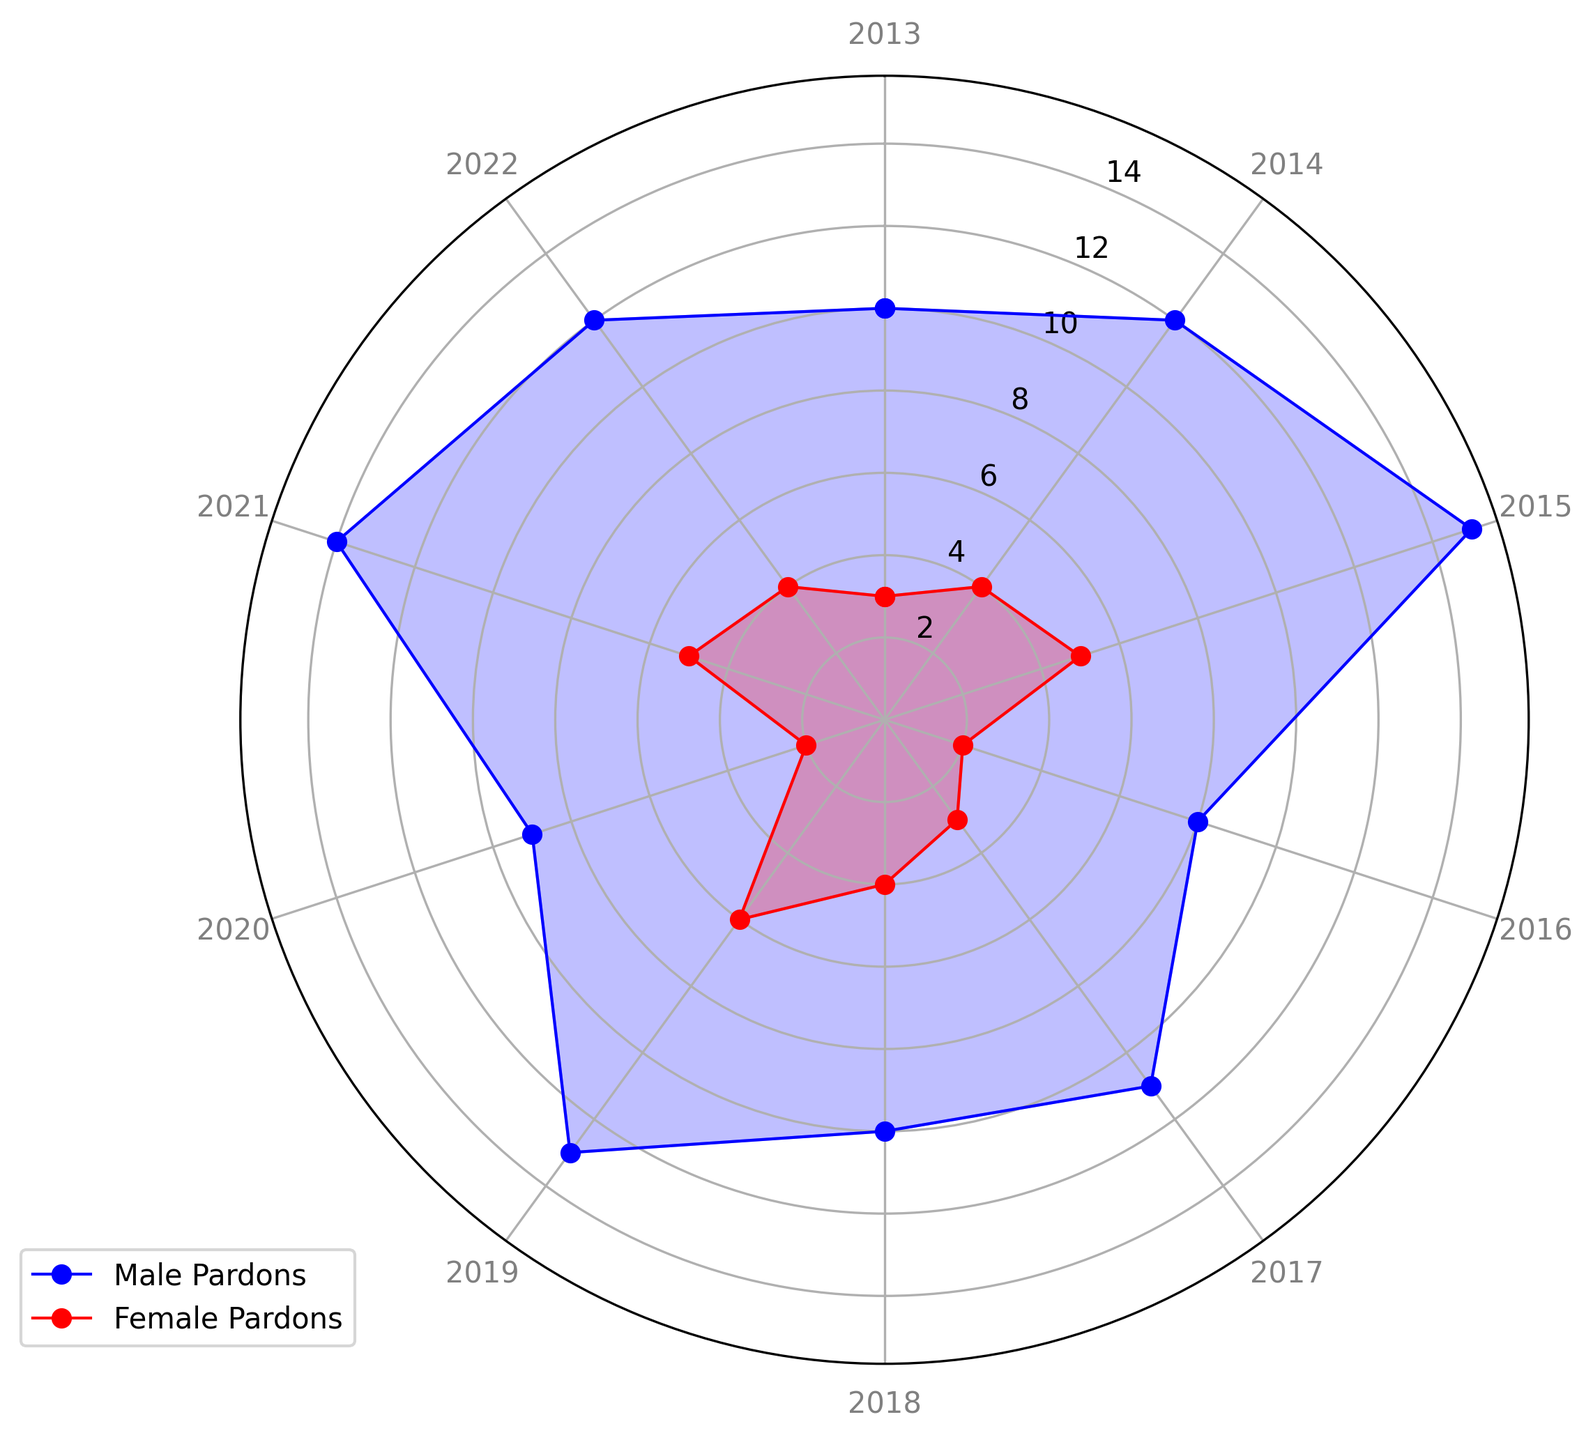What's the total number of pardons (male and female) granted in 2015? Refer to the figure, look for the value corresponding to 2015. The male pardons are 15, and the female pardons are 5. Add these values together: 15 (male) + 5 (female) = 20.
Answer: 20 In which year were the male pardons highest? In the figure, observe the blue line (representing male pardons) to find the year with the highest value. The peak value is at year 2015.
Answer: 2015 Comparing 2020 and 2021, which year had more female pardons and by how much? Check the red line (female pardons) for the values corresponding to 2020 and 2021. In 2020, the value is 2; in 2021, it's 5. Calculate the difference: 5 (2021) - 2 (2020) = 3.
Answer: 2021, by 3 pardons In how many years did the number of male pardons exceed the number of female pardons by more than 7? Compare the blue and red lines year by year: 2013 (10-3=7), 2014 (12-4=8), 2015 (15-5=10), 2016 (8-2=6), 2017 (11-3=8), 2018 (10-4=6), 2019 (13-6=7), 2020 (9-2=7), 2021 (14-5=9), 2022 (12-4=8). The years are 2014, 2015, 2017, 2021, and 2022. There are 5 years in total.
Answer: 5 Which year showed the lowest number of pardons for both genders combined? Identify the year with the smallest combined value by summing both lines' values for each year. The smallest combined value is 10 (male) + 2 (female) = 12 in 2016.
Answer: 2016 